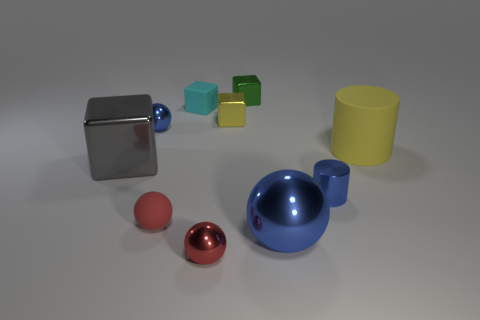Subtract all balls. How many objects are left? 6 Subtract all small blue metal spheres. Subtract all big spheres. How many objects are left? 8 Add 5 large metallic spheres. How many large metallic spheres are left? 6 Add 6 big objects. How many big objects exist? 9 Subtract 0 brown cylinders. How many objects are left? 10 